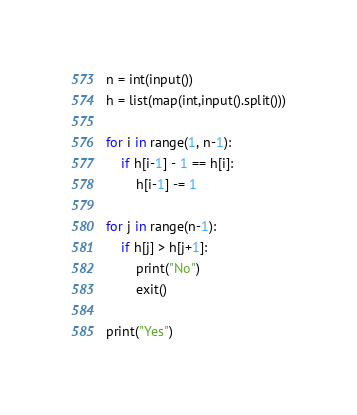<code> <loc_0><loc_0><loc_500><loc_500><_Python_>n = int(input())
h = list(map(int,input().split()))

for i in range(1, n-1):
    if h[i-1] - 1 == h[i]:
        h[i-1] -= 1

for j in range(n-1):
    if h[j] > h[j+1]:
        print("No")
        exit()

print("Yes")</code> 